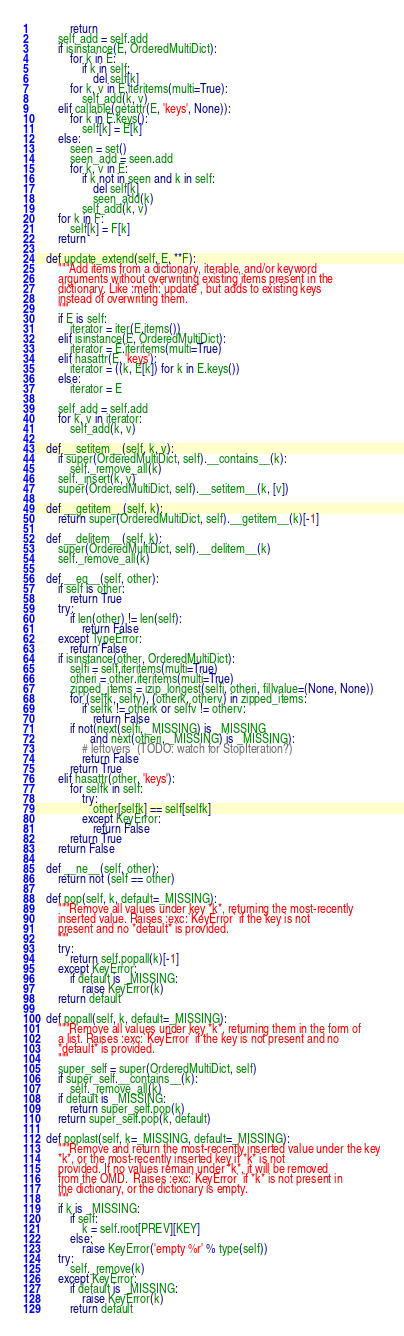Convert code to text. <code><loc_0><loc_0><loc_500><loc_500><_Python_>            return
        self_add = self.add
        if isinstance(E, OrderedMultiDict):
            for k in E:
                if k in self:
                    del self[k]
            for k, v in E.iteritems(multi=True):
                self_add(k, v)
        elif callable(getattr(E, 'keys', None)):
            for k in E.keys():
                self[k] = E[k]
        else:
            seen = set()
            seen_add = seen.add
            for k, v in E:
                if k not in seen and k in self:
                    del self[k]
                    seen_add(k)
                self_add(k, v)
        for k in F:
            self[k] = F[k]
        return

    def update_extend(self, E, **F):
        """Add items from a dictionary, iterable, and/or keyword
        arguments without overwriting existing items present in the
        dictionary. Like :meth:`update`, but adds to existing keys
        instead of overwriting them.
        """
        if E is self:
            iterator = iter(E.items())
        elif isinstance(E, OrderedMultiDict):
            iterator = E.iteritems(multi=True)
        elif hasattr(E, 'keys'):
            iterator = ((k, E[k]) for k in E.keys())
        else:
            iterator = E

        self_add = self.add
        for k, v in iterator:
            self_add(k, v)

    def __setitem__(self, k, v):
        if super(OrderedMultiDict, self).__contains__(k):
            self._remove_all(k)
        self._insert(k, v)
        super(OrderedMultiDict, self).__setitem__(k, [v])

    def __getitem__(self, k):
        return super(OrderedMultiDict, self).__getitem__(k)[-1]

    def __delitem__(self, k):
        super(OrderedMultiDict, self).__delitem__(k)
        self._remove_all(k)

    def __eq__(self, other):
        if self is other:
            return True
        try:
            if len(other) != len(self):
                return False
        except TypeError:
            return False
        if isinstance(other, OrderedMultiDict):
            selfi = self.iteritems(multi=True)
            otheri = other.iteritems(multi=True)
            zipped_items = izip_longest(selfi, otheri, fillvalue=(None, None))
            for (selfk, selfv), (otherk, otherv) in zipped_items:
                if selfk != otherk or selfv != otherv:
                    return False
            if not(next(selfi, _MISSING) is _MISSING
                   and next(otheri, _MISSING) is _MISSING):
                # leftovers  (TODO: watch for StopIteration?)
                return False
            return True
        elif hasattr(other, 'keys'):
            for selfk in self:
                try:
                    other[selfk] == self[selfk]
                except KeyError:
                    return False
            return True
        return False

    def __ne__(self, other):
        return not (self == other)

    def pop(self, k, default=_MISSING):
        """Remove all values under key *k*, returning the most-recently
        inserted value. Raises :exc:`KeyError` if the key is not
        present and no *default* is provided.
        """
        try:
            return self.popall(k)[-1]
        except KeyError:
            if default is _MISSING:
                raise KeyError(k)
        return default

    def popall(self, k, default=_MISSING):
        """Remove all values under key *k*, returning them in the form of
        a list. Raises :exc:`KeyError` if the key is not present and no
        *default* is provided.
        """
        super_self = super(OrderedMultiDict, self)
        if super_self.__contains__(k):
            self._remove_all(k)
        if default is _MISSING:
            return super_self.pop(k)
        return super_self.pop(k, default)

    def poplast(self, k=_MISSING, default=_MISSING):
        """Remove and return the most-recently inserted value under the key
        *k*, or the most-recently inserted key if *k* is not
        provided. If no values remain under *k*, it will be removed
        from the OMD.  Raises :exc:`KeyError` if *k* is not present in
        the dictionary, or the dictionary is empty.
        """
        if k is _MISSING:
            if self:
                k = self.root[PREV][KEY]
            else:
                raise KeyError('empty %r' % type(self))
        try:
            self._remove(k)
        except KeyError:
            if default is _MISSING:
                raise KeyError(k)
            return default</code> 